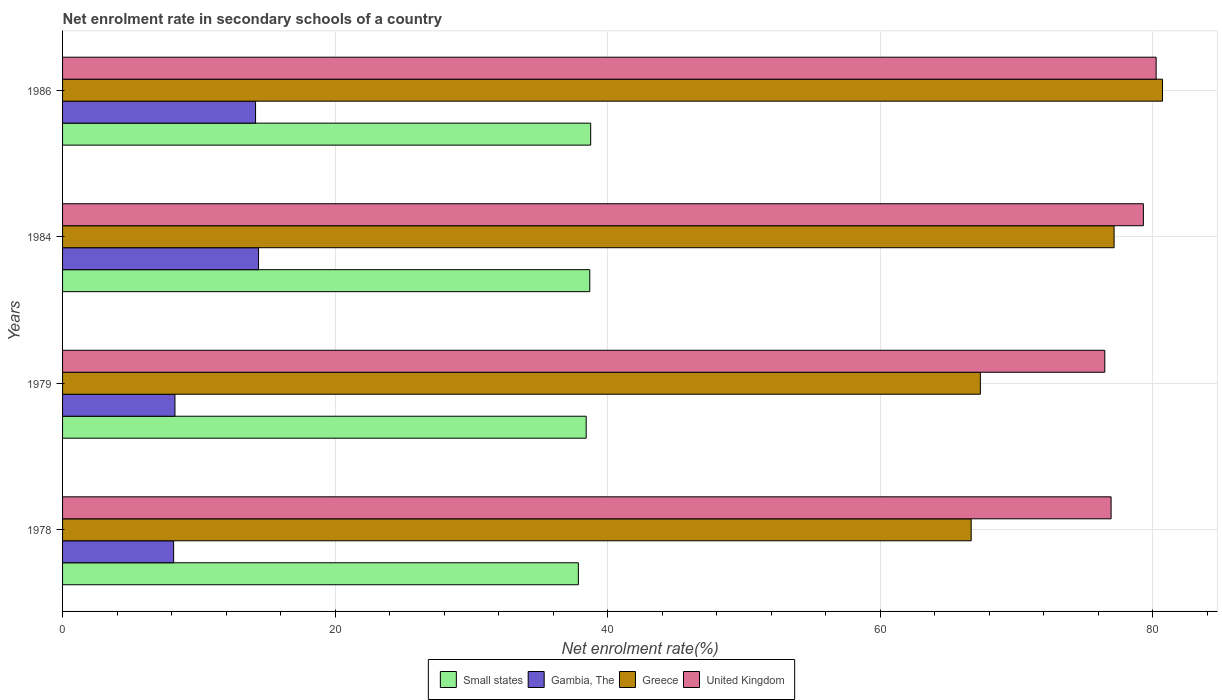How many different coloured bars are there?
Provide a succinct answer. 4. How many groups of bars are there?
Offer a very short reply. 4. Are the number of bars on each tick of the Y-axis equal?
Your answer should be very brief. Yes. How many bars are there on the 1st tick from the bottom?
Your answer should be very brief. 4. What is the label of the 3rd group of bars from the top?
Make the answer very short. 1979. In how many cases, is the number of bars for a given year not equal to the number of legend labels?
Your response must be concise. 0. What is the net enrolment rate in secondary schools in Small states in 1979?
Your response must be concise. 38.43. Across all years, what is the maximum net enrolment rate in secondary schools in United Kingdom?
Offer a very short reply. 80.26. Across all years, what is the minimum net enrolment rate in secondary schools in Gambia, The?
Provide a succinct answer. 8.15. In which year was the net enrolment rate in secondary schools in Small states maximum?
Keep it short and to the point. 1986. In which year was the net enrolment rate in secondary schools in Small states minimum?
Provide a short and direct response. 1978. What is the total net enrolment rate in secondary schools in United Kingdom in the graph?
Make the answer very short. 313.03. What is the difference between the net enrolment rate in secondary schools in Greece in 1978 and that in 1984?
Your answer should be very brief. -10.49. What is the difference between the net enrolment rate in secondary schools in Gambia, The in 1979 and the net enrolment rate in secondary schools in Greece in 1984?
Your answer should be compact. -68.93. What is the average net enrolment rate in secondary schools in Greece per year?
Your answer should be compact. 72.99. In the year 1984, what is the difference between the net enrolment rate in secondary schools in United Kingdom and net enrolment rate in secondary schools in Gambia, The?
Provide a succinct answer. 64.94. What is the ratio of the net enrolment rate in secondary schools in Small states in 1979 to that in 1986?
Your answer should be compact. 0.99. Is the net enrolment rate in secondary schools in Gambia, The in 1978 less than that in 1979?
Keep it short and to the point. Yes. Is the difference between the net enrolment rate in secondary schools in United Kingdom in 1979 and 1984 greater than the difference between the net enrolment rate in secondary schools in Gambia, The in 1979 and 1984?
Offer a terse response. Yes. What is the difference between the highest and the second highest net enrolment rate in secondary schools in Small states?
Offer a very short reply. 0.07. What is the difference between the highest and the lowest net enrolment rate in secondary schools in Greece?
Your answer should be very brief. 14.04. In how many years, is the net enrolment rate in secondary schools in Greece greater than the average net enrolment rate in secondary schools in Greece taken over all years?
Keep it short and to the point. 2. Is the sum of the net enrolment rate in secondary schools in Small states in 1979 and 1984 greater than the maximum net enrolment rate in secondary schools in Gambia, The across all years?
Ensure brevity in your answer.  Yes. What does the 4th bar from the top in 1984 represents?
Keep it short and to the point. Small states. What does the 4th bar from the bottom in 1979 represents?
Keep it short and to the point. United Kingdom. How many years are there in the graph?
Make the answer very short. 4. What is the difference between two consecutive major ticks on the X-axis?
Offer a very short reply. 20. Does the graph contain any zero values?
Your answer should be very brief. No. Does the graph contain grids?
Offer a terse response. Yes. How are the legend labels stacked?
Give a very brief answer. Horizontal. What is the title of the graph?
Offer a terse response. Net enrolment rate in secondary schools of a country. What is the label or title of the X-axis?
Your response must be concise. Net enrolment rate(%). What is the label or title of the Y-axis?
Ensure brevity in your answer.  Years. What is the Net enrolment rate(%) in Small states in 1978?
Give a very brief answer. 37.85. What is the Net enrolment rate(%) in Gambia, The in 1978?
Keep it short and to the point. 8.15. What is the Net enrolment rate(%) of Greece in 1978?
Keep it short and to the point. 66.68. What is the Net enrolment rate(%) of United Kingdom in 1978?
Your answer should be very brief. 76.95. What is the Net enrolment rate(%) of Small states in 1979?
Provide a short and direct response. 38.43. What is the Net enrolment rate(%) in Gambia, The in 1979?
Ensure brevity in your answer.  8.25. What is the Net enrolment rate(%) of Greece in 1979?
Offer a terse response. 67.36. What is the Net enrolment rate(%) of United Kingdom in 1979?
Offer a very short reply. 76.49. What is the Net enrolment rate(%) in Small states in 1984?
Provide a succinct answer. 38.69. What is the Net enrolment rate(%) in Gambia, The in 1984?
Your response must be concise. 14.38. What is the Net enrolment rate(%) of Greece in 1984?
Provide a short and direct response. 77.17. What is the Net enrolment rate(%) in United Kingdom in 1984?
Give a very brief answer. 79.32. What is the Net enrolment rate(%) of Small states in 1986?
Provide a succinct answer. 38.76. What is the Net enrolment rate(%) of Gambia, The in 1986?
Your answer should be very brief. 14.16. What is the Net enrolment rate(%) in Greece in 1986?
Offer a very short reply. 80.73. What is the Net enrolment rate(%) of United Kingdom in 1986?
Your answer should be compact. 80.26. Across all years, what is the maximum Net enrolment rate(%) in Small states?
Give a very brief answer. 38.76. Across all years, what is the maximum Net enrolment rate(%) of Gambia, The?
Your answer should be very brief. 14.38. Across all years, what is the maximum Net enrolment rate(%) of Greece?
Offer a very short reply. 80.73. Across all years, what is the maximum Net enrolment rate(%) of United Kingdom?
Offer a terse response. 80.26. Across all years, what is the minimum Net enrolment rate(%) of Small states?
Your answer should be compact. 37.85. Across all years, what is the minimum Net enrolment rate(%) in Gambia, The?
Provide a short and direct response. 8.15. Across all years, what is the minimum Net enrolment rate(%) of Greece?
Ensure brevity in your answer.  66.68. Across all years, what is the minimum Net enrolment rate(%) in United Kingdom?
Give a very brief answer. 76.49. What is the total Net enrolment rate(%) of Small states in the graph?
Your response must be concise. 153.74. What is the total Net enrolment rate(%) of Gambia, The in the graph?
Make the answer very short. 44.95. What is the total Net enrolment rate(%) of Greece in the graph?
Offer a terse response. 291.94. What is the total Net enrolment rate(%) in United Kingdom in the graph?
Offer a very short reply. 313.03. What is the difference between the Net enrolment rate(%) of Small states in 1978 and that in 1979?
Make the answer very short. -0.57. What is the difference between the Net enrolment rate(%) of Gambia, The in 1978 and that in 1979?
Ensure brevity in your answer.  -0.1. What is the difference between the Net enrolment rate(%) in Greece in 1978 and that in 1979?
Offer a terse response. -0.67. What is the difference between the Net enrolment rate(%) in United Kingdom in 1978 and that in 1979?
Ensure brevity in your answer.  0.46. What is the difference between the Net enrolment rate(%) of Small states in 1978 and that in 1984?
Offer a very short reply. -0.84. What is the difference between the Net enrolment rate(%) in Gambia, The in 1978 and that in 1984?
Your response must be concise. -6.23. What is the difference between the Net enrolment rate(%) in Greece in 1978 and that in 1984?
Provide a short and direct response. -10.49. What is the difference between the Net enrolment rate(%) of United Kingdom in 1978 and that in 1984?
Offer a terse response. -2.37. What is the difference between the Net enrolment rate(%) in Small states in 1978 and that in 1986?
Offer a terse response. -0.91. What is the difference between the Net enrolment rate(%) in Gambia, The in 1978 and that in 1986?
Your answer should be very brief. -6.01. What is the difference between the Net enrolment rate(%) of Greece in 1978 and that in 1986?
Offer a very short reply. -14.04. What is the difference between the Net enrolment rate(%) in United Kingdom in 1978 and that in 1986?
Offer a very short reply. -3.31. What is the difference between the Net enrolment rate(%) in Small states in 1979 and that in 1984?
Make the answer very short. -0.26. What is the difference between the Net enrolment rate(%) in Gambia, The in 1979 and that in 1984?
Give a very brief answer. -6.13. What is the difference between the Net enrolment rate(%) in Greece in 1979 and that in 1984?
Provide a succinct answer. -9.82. What is the difference between the Net enrolment rate(%) of United Kingdom in 1979 and that in 1984?
Give a very brief answer. -2.83. What is the difference between the Net enrolment rate(%) of Small states in 1979 and that in 1986?
Keep it short and to the point. -0.33. What is the difference between the Net enrolment rate(%) in Gambia, The in 1979 and that in 1986?
Ensure brevity in your answer.  -5.92. What is the difference between the Net enrolment rate(%) in Greece in 1979 and that in 1986?
Ensure brevity in your answer.  -13.37. What is the difference between the Net enrolment rate(%) in United Kingdom in 1979 and that in 1986?
Your answer should be compact. -3.77. What is the difference between the Net enrolment rate(%) in Small states in 1984 and that in 1986?
Your response must be concise. -0.07. What is the difference between the Net enrolment rate(%) of Gambia, The in 1984 and that in 1986?
Provide a short and direct response. 0.22. What is the difference between the Net enrolment rate(%) of Greece in 1984 and that in 1986?
Ensure brevity in your answer.  -3.55. What is the difference between the Net enrolment rate(%) in United Kingdom in 1984 and that in 1986?
Ensure brevity in your answer.  -0.94. What is the difference between the Net enrolment rate(%) of Small states in 1978 and the Net enrolment rate(%) of Gambia, The in 1979?
Your answer should be compact. 29.61. What is the difference between the Net enrolment rate(%) of Small states in 1978 and the Net enrolment rate(%) of Greece in 1979?
Offer a very short reply. -29.5. What is the difference between the Net enrolment rate(%) in Small states in 1978 and the Net enrolment rate(%) in United Kingdom in 1979?
Offer a terse response. -38.64. What is the difference between the Net enrolment rate(%) of Gambia, The in 1978 and the Net enrolment rate(%) of Greece in 1979?
Provide a short and direct response. -59.21. What is the difference between the Net enrolment rate(%) of Gambia, The in 1978 and the Net enrolment rate(%) of United Kingdom in 1979?
Make the answer very short. -68.34. What is the difference between the Net enrolment rate(%) of Greece in 1978 and the Net enrolment rate(%) of United Kingdom in 1979?
Provide a short and direct response. -9.81. What is the difference between the Net enrolment rate(%) of Small states in 1978 and the Net enrolment rate(%) of Gambia, The in 1984?
Offer a terse response. 23.47. What is the difference between the Net enrolment rate(%) of Small states in 1978 and the Net enrolment rate(%) of Greece in 1984?
Provide a succinct answer. -39.32. What is the difference between the Net enrolment rate(%) in Small states in 1978 and the Net enrolment rate(%) in United Kingdom in 1984?
Your response must be concise. -41.47. What is the difference between the Net enrolment rate(%) of Gambia, The in 1978 and the Net enrolment rate(%) of Greece in 1984?
Make the answer very short. -69.02. What is the difference between the Net enrolment rate(%) of Gambia, The in 1978 and the Net enrolment rate(%) of United Kingdom in 1984?
Your answer should be compact. -71.17. What is the difference between the Net enrolment rate(%) in Greece in 1978 and the Net enrolment rate(%) in United Kingdom in 1984?
Give a very brief answer. -12.64. What is the difference between the Net enrolment rate(%) of Small states in 1978 and the Net enrolment rate(%) of Gambia, The in 1986?
Provide a succinct answer. 23.69. What is the difference between the Net enrolment rate(%) of Small states in 1978 and the Net enrolment rate(%) of Greece in 1986?
Offer a very short reply. -42.87. What is the difference between the Net enrolment rate(%) in Small states in 1978 and the Net enrolment rate(%) in United Kingdom in 1986?
Keep it short and to the point. -42.4. What is the difference between the Net enrolment rate(%) of Gambia, The in 1978 and the Net enrolment rate(%) of Greece in 1986?
Give a very brief answer. -72.57. What is the difference between the Net enrolment rate(%) in Gambia, The in 1978 and the Net enrolment rate(%) in United Kingdom in 1986?
Provide a succinct answer. -72.11. What is the difference between the Net enrolment rate(%) of Greece in 1978 and the Net enrolment rate(%) of United Kingdom in 1986?
Make the answer very short. -13.57. What is the difference between the Net enrolment rate(%) in Small states in 1979 and the Net enrolment rate(%) in Gambia, The in 1984?
Ensure brevity in your answer.  24.05. What is the difference between the Net enrolment rate(%) of Small states in 1979 and the Net enrolment rate(%) of Greece in 1984?
Keep it short and to the point. -38.74. What is the difference between the Net enrolment rate(%) of Small states in 1979 and the Net enrolment rate(%) of United Kingdom in 1984?
Offer a terse response. -40.89. What is the difference between the Net enrolment rate(%) of Gambia, The in 1979 and the Net enrolment rate(%) of Greece in 1984?
Provide a succinct answer. -68.93. What is the difference between the Net enrolment rate(%) of Gambia, The in 1979 and the Net enrolment rate(%) of United Kingdom in 1984?
Your response must be concise. -71.07. What is the difference between the Net enrolment rate(%) of Greece in 1979 and the Net enrolment rate(%) of United Kingdom in 1984?
Your answer should be very brief. -11.96. What is the difference between the Net enrolment rate(%) in Small states in 1979 and the Net enrolment rate(%) in Gambia, The in 1986?
Ensure brevity in your answer.  24.27. What is the difference between the Net enrolment rate(%) of Small states in 1979 and the Net enrolment rate(%) of Greece in 1986?
Offer a terse response. -42.3. What is the difference between the Net enrolment rate(%) in Small states in 1979 and the Net enrolment rate(%) in United Kingdom in 1986?
Give a very brief answer. -41.83. What is the difference between the Net enrolment rate(%) of Gambia, The in 1979 and the Net enrolment rate(%) of Greece in 1986?
Your answer should be compact. -72.48. What is the difference between the Net enrolment rate(%) of Gambia, The in 1979 and the Net enrolment rate(%) of United Kingdom in 1986?
Ensure brevity in your answer.  -72.01. What is the difference between the Net enrolment rate(%) in Greece in 1979 and the Net enrolment rate(%) in United Kingdom in 1986?
Offer a very short reply. -12.9. What is the difference between the Net enrolment rate(%) of Small states in 1984 and the Net enrolment rate(%) of Gambia, The in 1986?
Your answer should be compact. 24.53. What is the difference between the Net enrolment rate(%) of Small states in 1984 and the Net enrolment rate(%) of Greece in 1986?
Your answer should be very brief. -42.03. What is the difference between the Net enrolment rate(%) in Small states in 1984 and the Net enrolment rate(%) in United Kingdom in 1986?
Keep it short and to the point. -41.57. What is the difference between the Net enrolment rate(%) in Gambia, The in 1984 and the Net enrolment rate(%) in Greece in 1986?
Provide a short and direct response. -66.34. What is the difference between the Net enrolment rate(%) of Gambia, The in 1984 and the Net enrolment rate(%) of United Kingdom in 1986?
Provide a succinct answer. -65.88. What is the difference between the Net enrolment rate(%) of Greece in 1984 and the Net enrolment rate(%) of United Kingdom in 1986?
Offer a terse response. -3.09. What is the average Net enrolment rate(%) of Small states per year?
Keep it short and to the point. 38.43. What is the average Net enrolment rate(%) in Gambia, The per year?
Give a very brief answer. 11.24. What is the average Net enrolment rate(%) of Greece per year?
Provide a succinct answer. 72.99. What is the average Net enrolment rate(%) in United Kingdom per year?
Offer a terse response. 78.26. In the year 1978, what is the difference between the Net enrolment rate(%) of Small states and Net enrolment rate(%) of Gambia, The?
Your answer should be very brief. 29.7. In the year 1978, what is the difference between the Net enrolment rate(%) of Small states and Net enrolment rate(%) of Greece?
Offer a terse response. -28.83. In the year 1978, what is the difference between the Net enrolment rate(%) in Small states and Net enrolment rate(%) in United Kingdom?
Offer a very short reply. -39.1. In the year 1978, what is the difference between the Net enrolment rate(%) of Gambia, The and Net enrolment rate(%) of Greece?
Keep it short and to the point. -58.53. In the year 1978, what is the difference between the Net enrolment rate(%) in Gambia, The and Net enrolment rate(%) in United Kingdom?
Offer a very short reply. -68.8. In the year 1978, what is the difference between the Net enrolment rate(%) in Greece and Net enrolment rate(%) in United Kingdom?
Your answer should be very brief. -10.27. In the year 1979, what is the difference between the Net enrolment rate(%) in Small states and Net enrolment rate(%) in Gambia, The?
Provide a short and direct response. 30.18. In the year 1979, what is the difference between the Net enrolment rate(%) in Small states and Net enrolment rate(%) in Greece?
Offer a terse response. -28.93. In the year 1979, what is the difference between the Net enrolment rate(%) of Small states and Net enrolment rate(%) of United Kingdom?
Give a very brief answer. -38.06. In the year 1979, what is the difference between the Net enrolment rate(%) in Gambia, The and Net enrolment rate(%) in Greece?
Offer a very short reply. -59.11. In the year 1979, what is the difference between the Net enrolment rate(%) in Gambia, The and Net enrolment rate(%) in United Kingdom?
Keep it short and to the point. -68.24. In the year 1979, what is the difference between the Net enrolment rate(%) in Greece and Net enrolment rate(%) in United Kingdom?
Keep it short and to the point. -9.13. In the year 1984, what is the difference between the Net enrolment rate(%) in Small states and Net enrolment rate(%) in Gambia, The?
Ensure brevity in your answer.  24.31. In the year 1984, what is the difference between the Net enrolment rate(%) in Small states and Net enrolment rate(%) in Greece?
Provide a succinct answer. -38.48. In the year 1984, what is the difference between the Net enrolment rate(%) in Small states and Net enrolment rate(%) in United Kingdom?
Offer a very short reply. -40.63. In the year 1984, what is the difference between the Net enrolment rate(%) in Gambia, The and Net enrolment rate(%) in Greece?
Offer a very short reply. -62.79. In the year 1984, what is the difference between the Net enrolment rate(%) in Gambia, The and Net enrolment rate(%) in United Kingdom?
Your answer should be compact. -64.94. In the year 1984, what is the difference between the Net enrolment rate(%) of Greece and Net enrolment rate(%) of United Kingdom?
Offer a very short reply. -2.15. In the year 1986, what is the difference between the Net enrolment rate(%) of Small states and Net enrolment rate(%) of Gambia, The?
Offer a very short reply. 24.6. In the year 1986, what is the difference between the Net enrolment rate(%) of Small states and Net enrolment rate(%) of Greece?
Your answer should be very brief. -41.97. In the year 1986, what is the difference between the Net enrolment rate(%) in Small states and Net enrolment rate(%) in United Kingdom?
Provide a short and direct response. -41.5. In the year 1986, what is the difference between the Net enrolment rate(%) in Gambia, The and Net enrolment rate(%) in Greece?
Keep it short and to the point. -66.56. In the year 1986, what is the difference between the Net enrolment rate(%) in Gambia, The and Net enrolment rate(%) in United Kingdom?
Keep it short and to the point. -66.09. In the year 1986, what is the difference between the Net enrolment rate(%) in Greece and Net enrolment rate(%) in United Kingdom?
Your answer should be compact. 0.47. What is the ratio of the Net enrolment rate(%) of Small states in 1978 to that in 1979?
Your answer should be compact. 0.98. What is the ratio of the Net enrolment rate(%) of Gambia, The in 1978 to that in 1979?
Offer a terse response. 0.99. What is the ratio of the Net enrolment rate(%) in Small states in 1978 to that in 1984?
Provide a short and direct response. 0.98. What is the ratio of the Net enrolment rate(%) in Gambia, The in 1978 to that in 1984?
Provide a short and direct response. 0.57. What is the ratio of the Net enrolment rate(%) of Greece in 1978 to that in 1984?
Your answer should be compact. 0.86. What is the ratio of the Net enrolment rate(%) in United Kingdom in 1978 to that in 1984?
Make the answer very short. 0.97. What is the ratio of the Net enrolment rate(%) of Small states in 1978 to that in 1986?
Ensure brevity in your answer.  0.98. What is the ratio of the Net enrolment rate(%) in Gambia, The in 1978 to that in 1986?
Your answer should be very brief. 0.58. What is the ratio of the Net enrolment rate(%) in Greece in 1978 to that in 1986?
Give a very brief answer. 0.83. What is the ratio of the Net enrolment rate(%) in United Kingdom in 1978 to that in 1986?
Give a very brief answer. 0.96. What is the ratio of the Net enrolment rate(%) in Small states in 1979 to that in 1984?
Your answer should be compact. 0.99. What is the ratio of the Net enrolment rate(%) of Gambia, The in 1979 to that in 1984?
Your answer should be very brief. 0.57. What is the ratio of the Net enrolment rate(%) of Greece in 1979 to that in 1984?
Your answer should be very brief. 0.87. What is the ratio of the Net enrolment rate(%) of United Kingdom in 1979 to that in 1984?
Your answer should be very brief. 0.96. What is the ratio of the Net enrolment rate(%) of Gambia, The in 1979 to that in 1986?
Your answer should be very brief. 0.58. What is the ratio of the Net enrolment rate(%) in Greece in 1979 to that in 1986?
Your answer should be very brief. 0.83. What is the ratio of the Net enrolment rate(%) in United Kingdom in 1979 to that in 1986?
Ensure brevity in your answer.  0.95. What is the ratio of the Net enrolment rate(%) of Small states in 1984 to that in 1986?
Offer a very short reply. 1. What is the ratio of the Net enrolment rate(%) of Gambia, The in 1984 to that in 1986?
Ensure brevity in your answer.  1.02. What is the ratio of the Net enrolment rate(%) in Greece in 1984 to that in 1986?
Make the answer very short. 0.96. What is the ratio of the Net enrolment rate(%) in United Kingdom in 1984 to that in 1986?
Your response must be concise. 0.99. What is the difference between the highest and the second highest Net enrolment rate(%) of Small states?
Ensure brevity in your answer.  0.07. What is the difference between the highest and the second highest Net enrolment rate(%) of Gambia, The?
Provide a short and direct response. 0.22. What is the difference between the highest and the second highest Net enrolment rate(%) of Greece?
Provide a short and direct response. 3.55. What is the difference between the highest and the second highest Net enrolment rate(%) in United Kingdom?
Your response must be concise. 0.94. What is the difference between the highest and the lowest Net enrolment rate(%) in Small states?
Give a very brief answer. 0.91. What is the difference between the highest and the lowest Net enrolment rate(%) in Gambia, The?
Your response must be concise. 6.23. What is the difference between the highest and the lowest Net enrolment rate(%) in Greece?
Ensure brevity in your answer.  14.04. What is the difference between the highest and the lowest Net enrolment rate(%) in United Kingdom?
Make the answer very short. 3.77. 